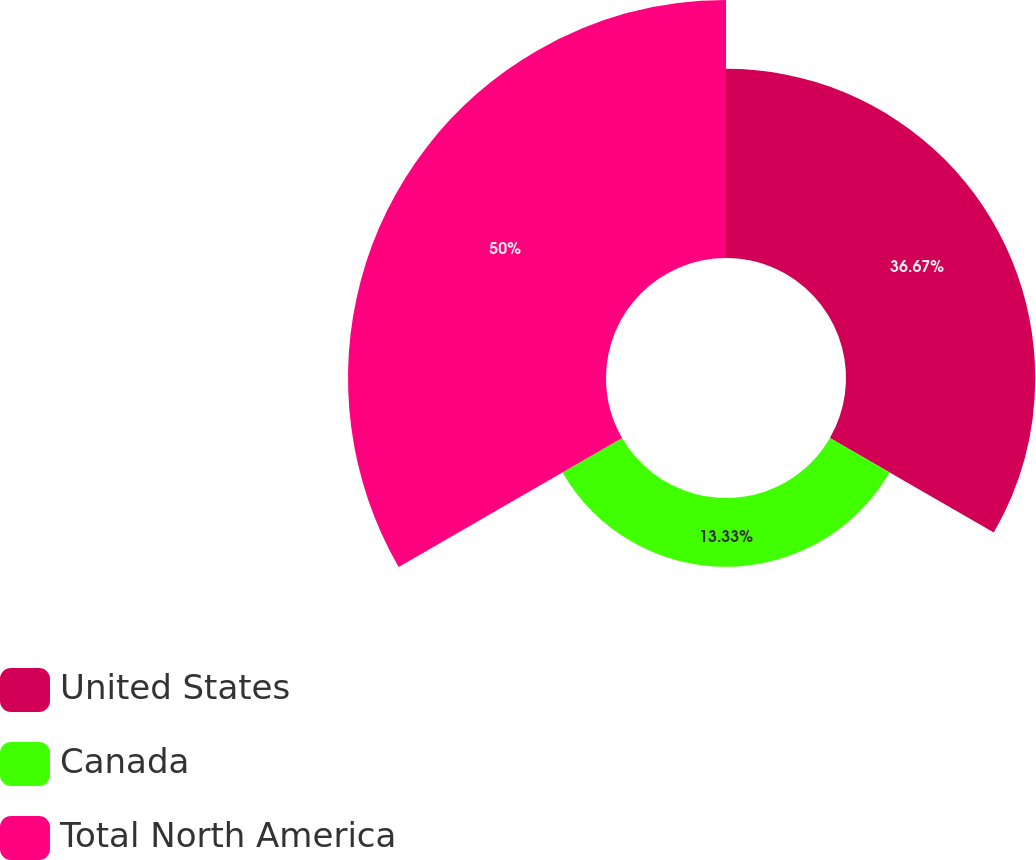<chart> <loc_0><loc_0><loc_500><loc_500><pie_chart><fcel>United States<fcel>Canada<fcel>Total North America<nl><fcel>36.67%<fcel>13.33%<fcel>50.0%<nl></chart> 